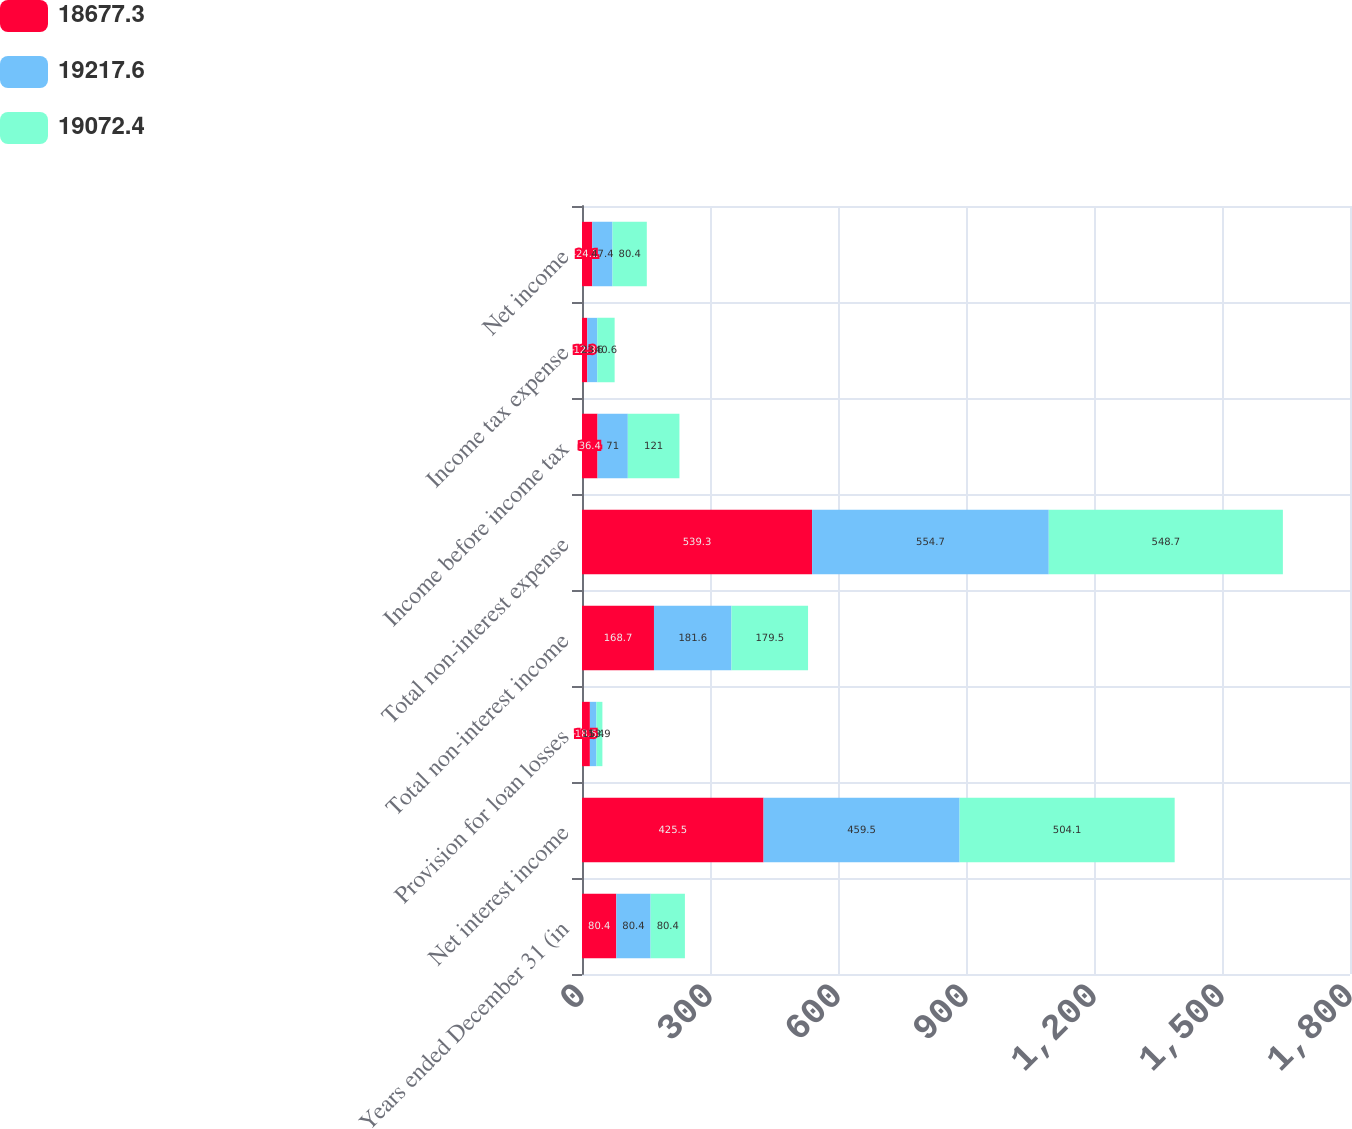Convert chart. <chart><loc_0><loc_0><loc_500><loc_500><stacked_bar_chart><ecel><fcel>Years ended December 31 (in<fcel>Net interest income<fcel>Provision for loan losses<fcel>Total non-interest income<fcel>Total non-interest expense<fcel>Income before income tax<fcel>Income tax expense<fcel>Net income<nl><fcel>18677.3<fcel>80.4<fcel>425.5<fcel>18.5<fcel>168.7<fcel>539.3<fcel>36.4<fcel>12.3<fcel>24.1<nl><fcel>19217.6<fcel>80.4<fcel>459.5<fcel>15.4<fcel>181.6<fcel>554.7<fcel>71<fcel>23.6<fcel>47.4<nl><fcel>19072.4<fcel>80.4<fcel>504.1<fcel>13.9<fcel>179.5<fcel>548.7<fcel>121<fcel>40.6<fcel>80.4<nl></chart> 